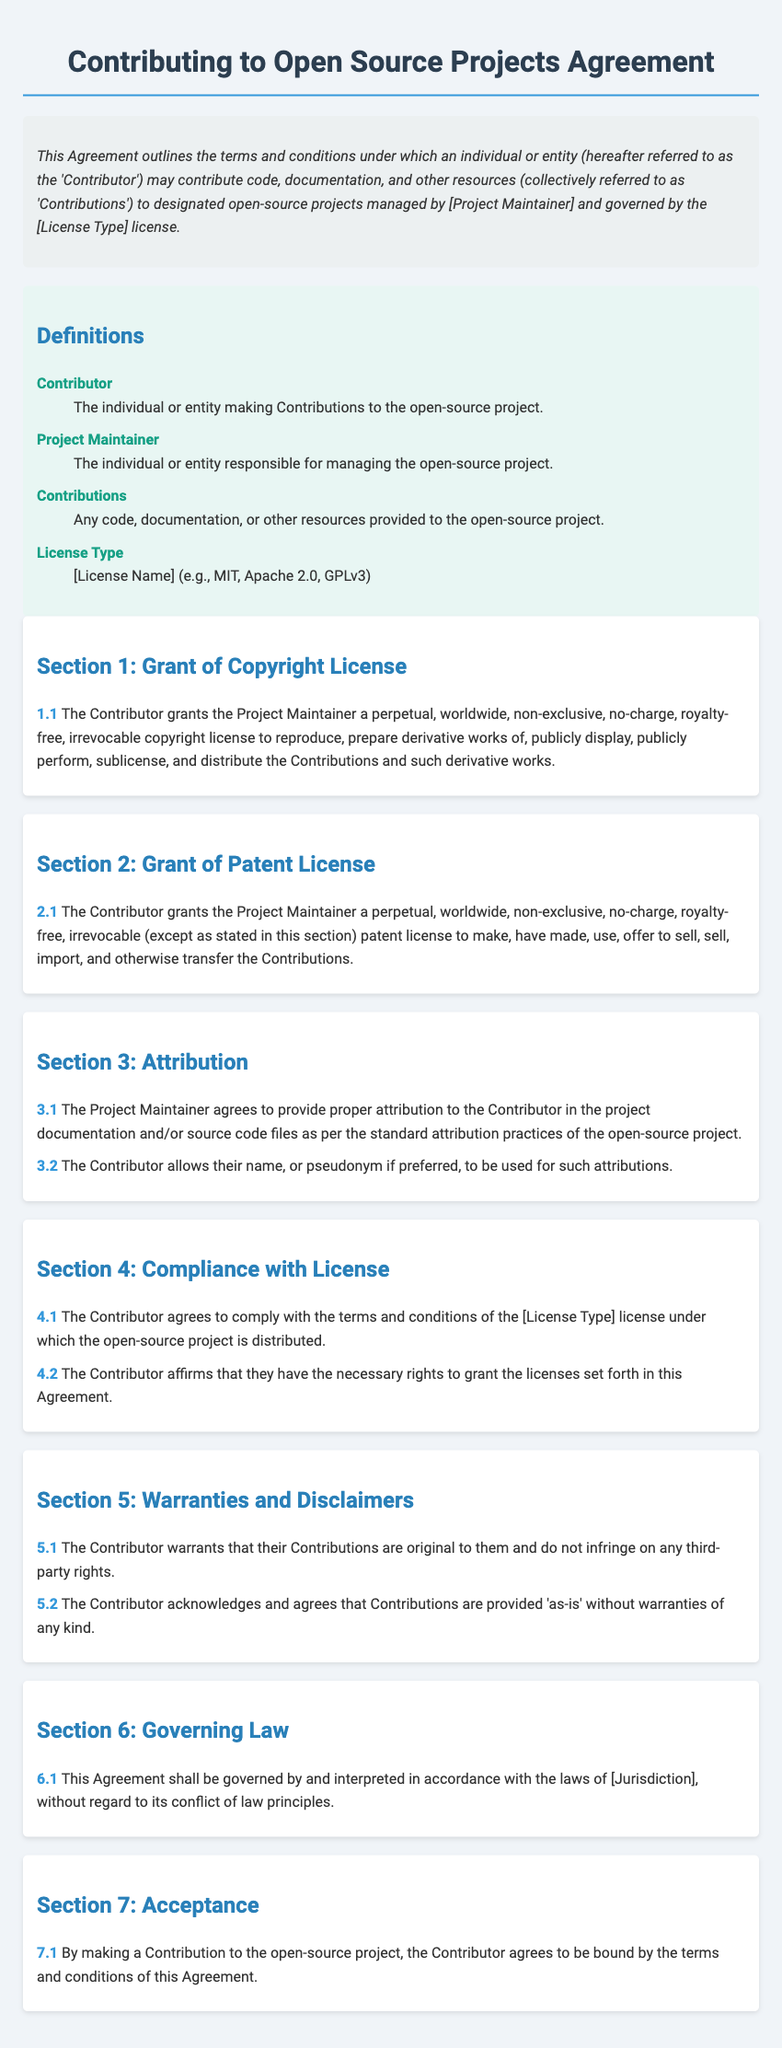What is the title of the document? The title is stated in the <title> tag of the document, which describes the subject matter.
Answer: Contributing to Open Source Projects Agreement Who is referred to as the 'Contributor'? The definition provided in the document specifies who the Contributor is in the context of the Agreement.
Answer: The individual or entity making Contributions to the open-source project What does the Contributor grant in Section 1? The clause in Section 1 outlines the rights granted to the Project Maintainer regarding Contributions made by the Contributor.
Answer: A perpetual, worldwide, non-exclusive, no-charge, royalty-free, irrevocable copyright license What is required for attribution in Section 3? Section 3 describes the obligations of the Project Maintainer concerning how they recognize the Contributor's work in documentation or source code.
Answer: Proper attribution to the Contributor in the project documentation What does the Contributor warrant about their Contributions in Section 5? The text in Section 5 clarifies what the Contributor guarantees regarding the originality and rights related to their Contributions.
Answer: Their Contributions are original to them and do not infringe on any third-party rights What type of license is discussed in the document? The definitions section specifies the category of license applicable to the open-source project and Contributions.
Answer: [License Name] (e.g., MIT, Apache 2.0, GPLv3) What governs the Agreement according to Section 6? The clause in Section 6 explains what legal framework or jurisdiction applies to the Agreement.
Answer: The laws of [Jurisdiction] What must the Contributor do to accept the Agreement in Section 7? The last section outlines the action required by the Contributor to signify their acceptance of the terms laid out in the Agreement.
Answer: By making a Contribution to the open-source project 